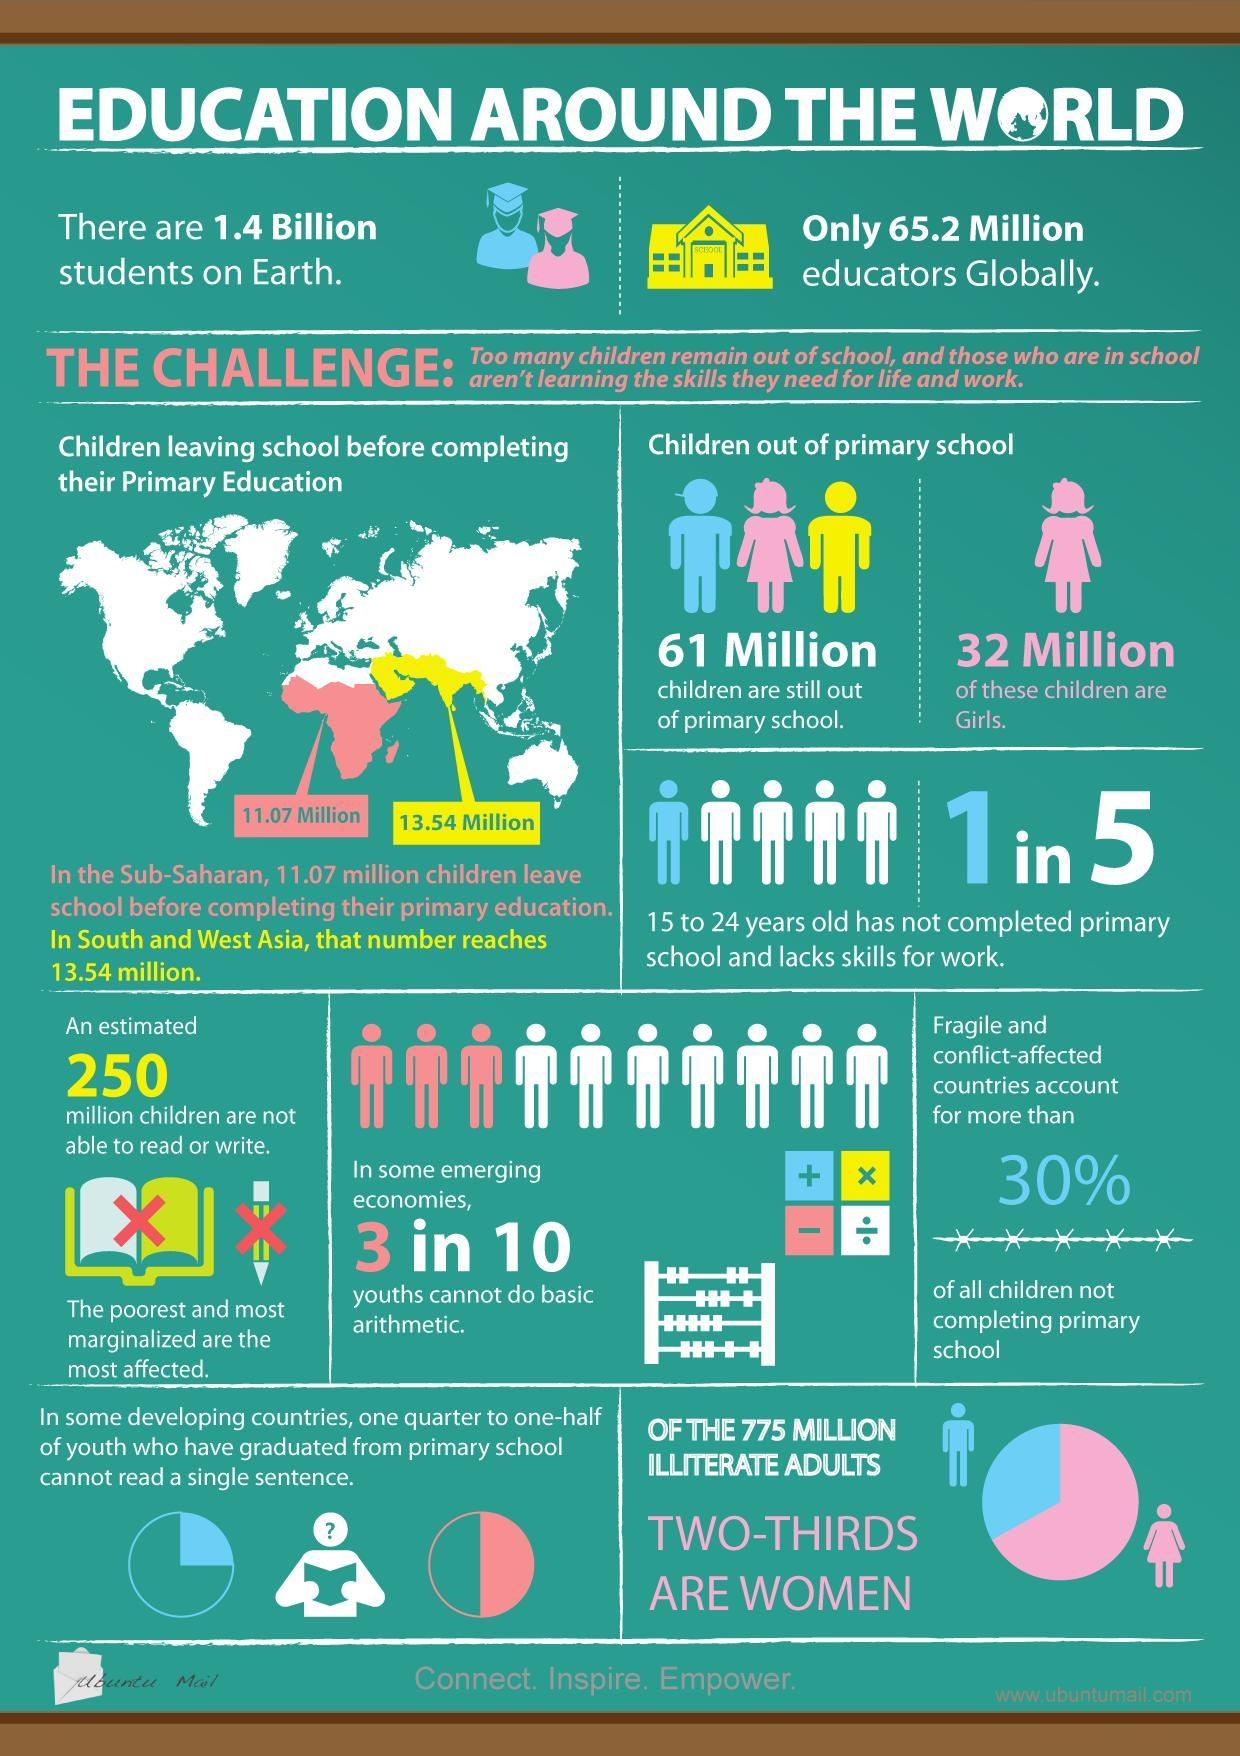What is the estimated population of children who are unable to read or write?
Answer the question with a short phrase. 250 million How many children are still out of primary school around the world? 61 Million 